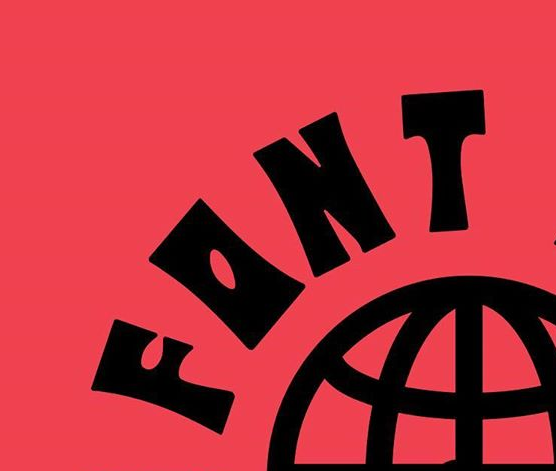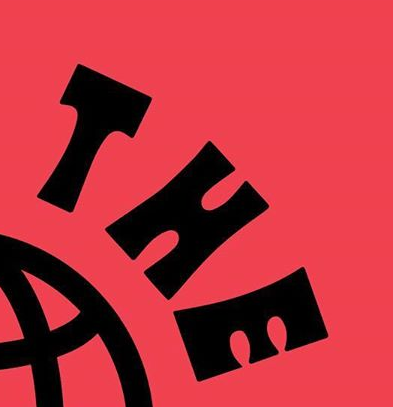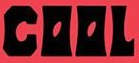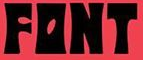Transcribe the words shown in these images in order, separated by a semicolon. FONT; THE; COOL; FONT 